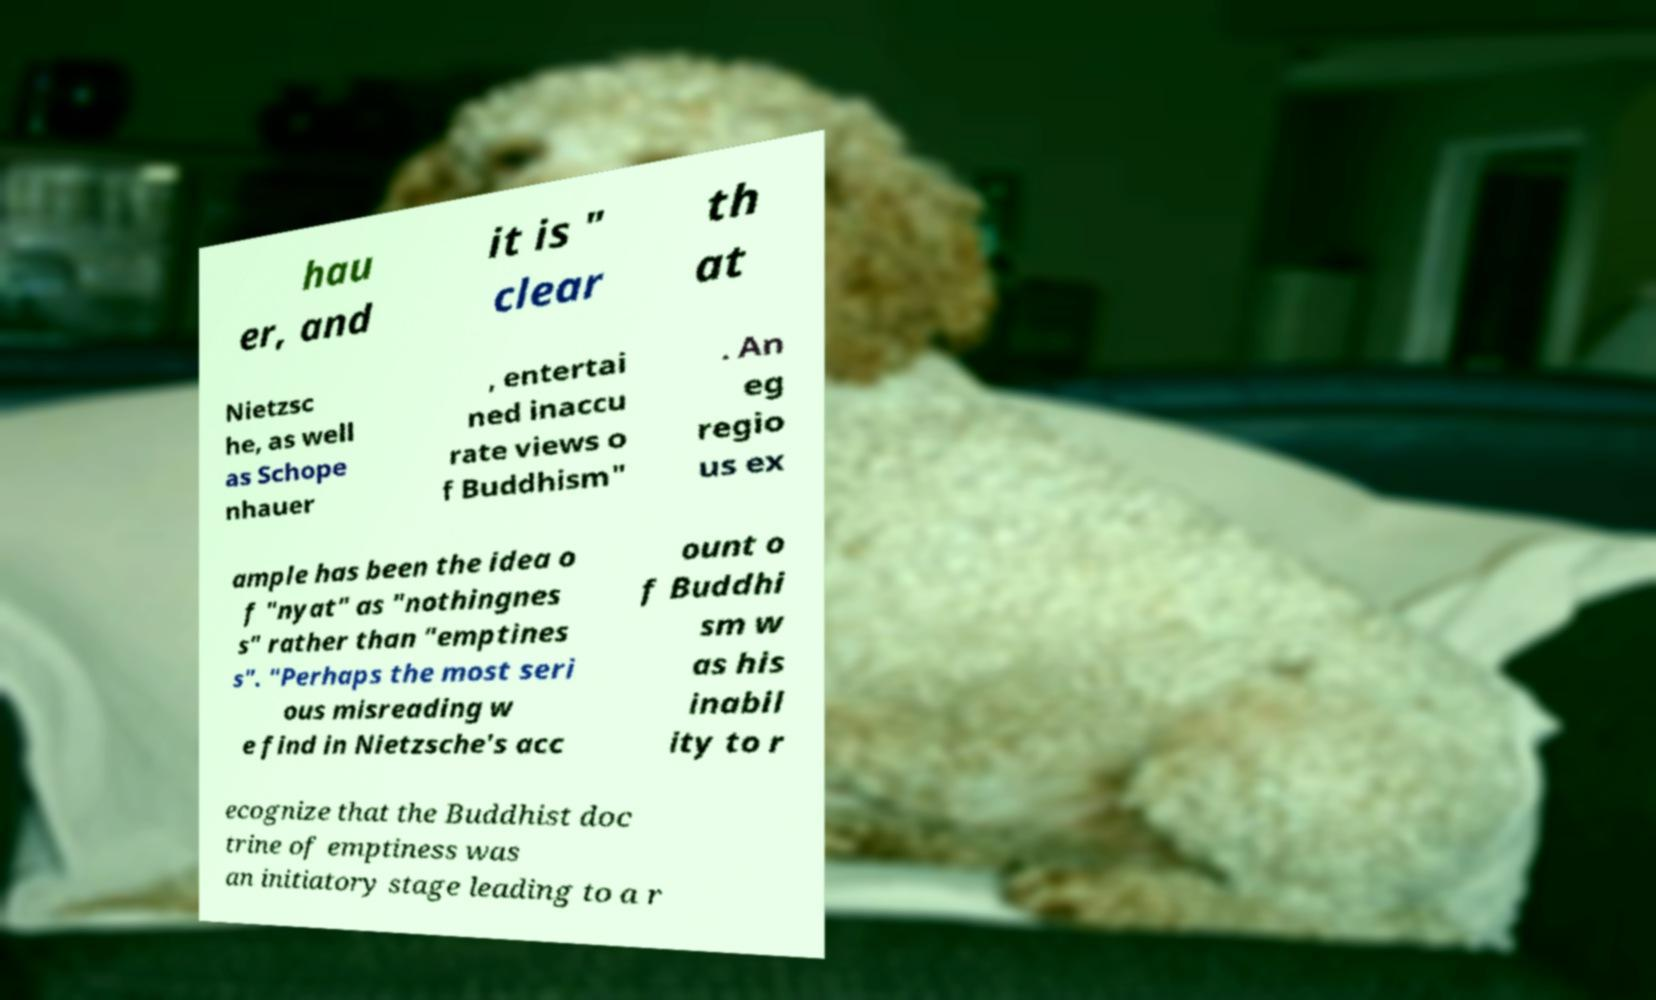What messages or text are displayed in this image? I need them in a readable, typed format. hau er, and it is " clear th at Nietzsc he, as well as Schope nhauer , entertai ned inaccu rate views o f Buddhism" . An eg regio us ex ample has been the idea o f "nyat" as "nothingnes s" rather than "emptines s". "Perhaps the most seri ous misreading w e find in Nietzsche's acc ount o f Buddhi sm w as his inabil ity to r ecognize that the Buddhist doc trine of emptiness was an initiatory stage leading to a r 